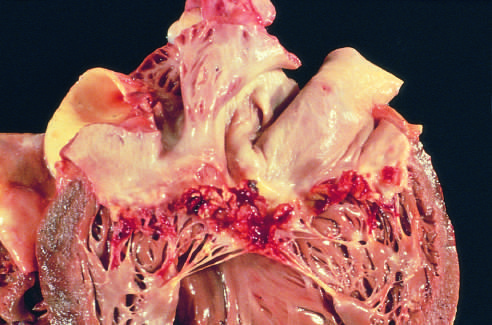s the transmural light area in the posterolateral left ventricle caused by streptococcus viridans on a previously myxomatous mitral valve?
Answer the question using a single word or phrase. No 